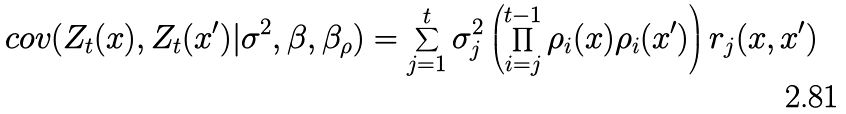<formula> <loc_0><loc_0><loc_500><loc_500>c o v ( Z _ { t } ( x ) , Z _ { t } ( x ^ { \prime } ) | \sigma ^ { 2 } , \beta , \beta _ { \rho } ) = \sum _ { j = 1 } ^ { t } { \sigma _ { j } ^ { 2 } \left ( \prod _ { i = j } ^ { t - 1 } { \rho _ { i } ( x ) \rho _ { i } ( x ^ { \prime } ) } \right ) r _ { j } ( x , x ^ { \prime } ) }</formula> 